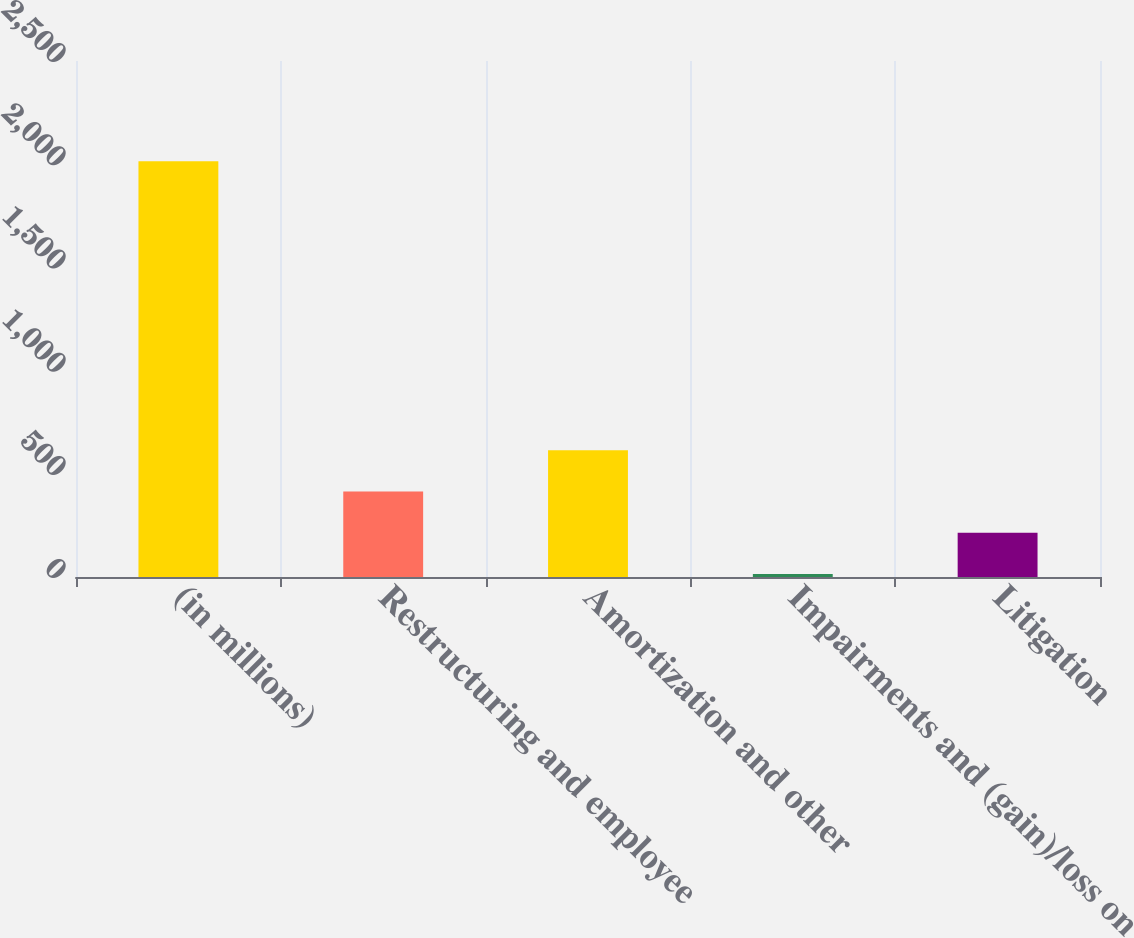Convert chart to OTSL. <chart><loc_0><loc_0><loc_500><loc_500><bar_chart><fcel>(in millions)<fcel>Restructuring and employee<fcel>Amortization and other<fcel>Impairments and (gain)/loss on<fcel>Litigation<nl><fcel>2014<fcel>414.8<fcel>614.7<fcel>15<fcel>214.9<nl></chart> 